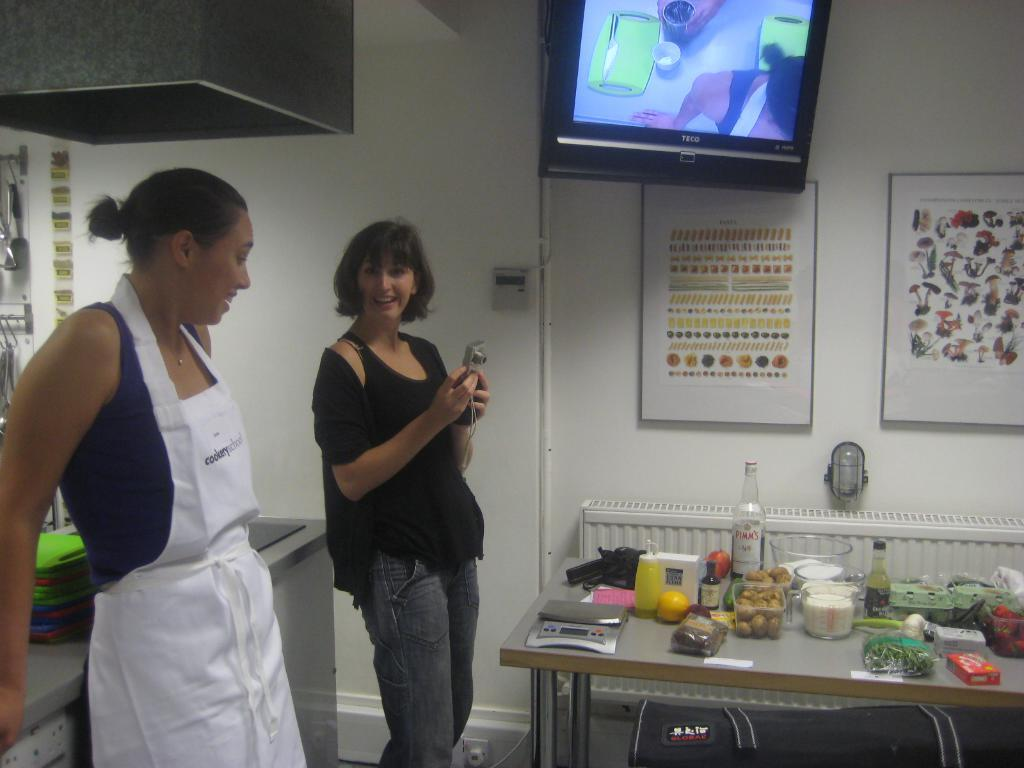<image>
Render a clear and concise summary of the photo. Two women affiliated with the Cookery School stand in front of a table of ingredients. 